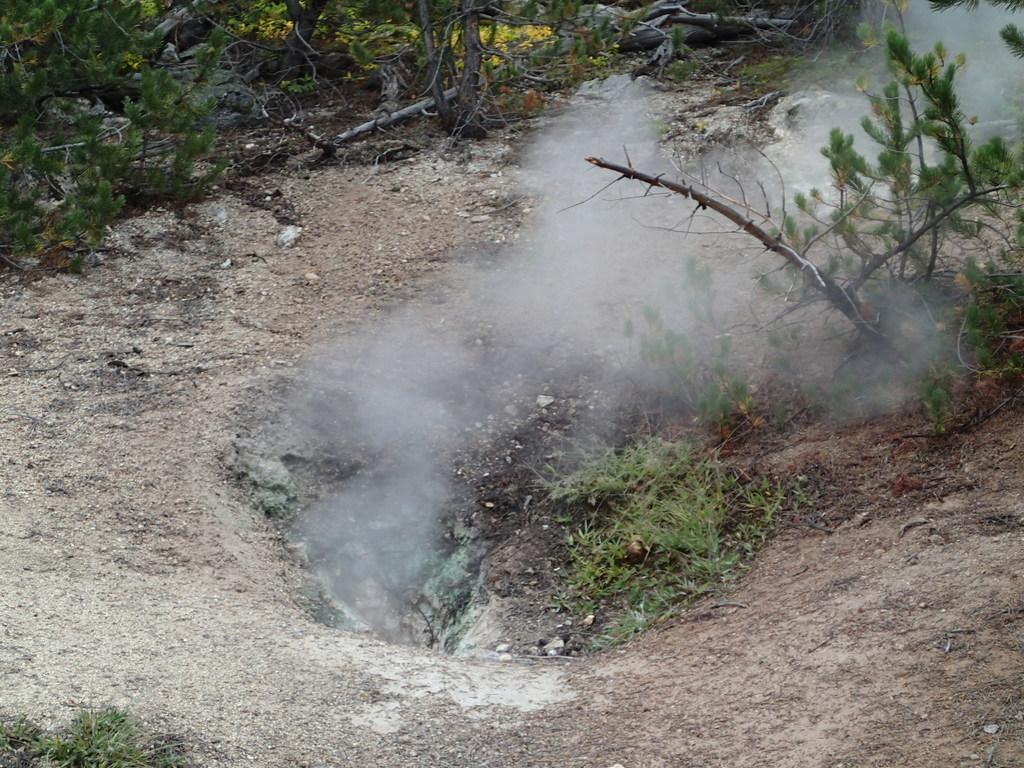In one or two sentences, can you explain what this image depicts? In the middle we can see smoke and there are plants and grass on the ground. 